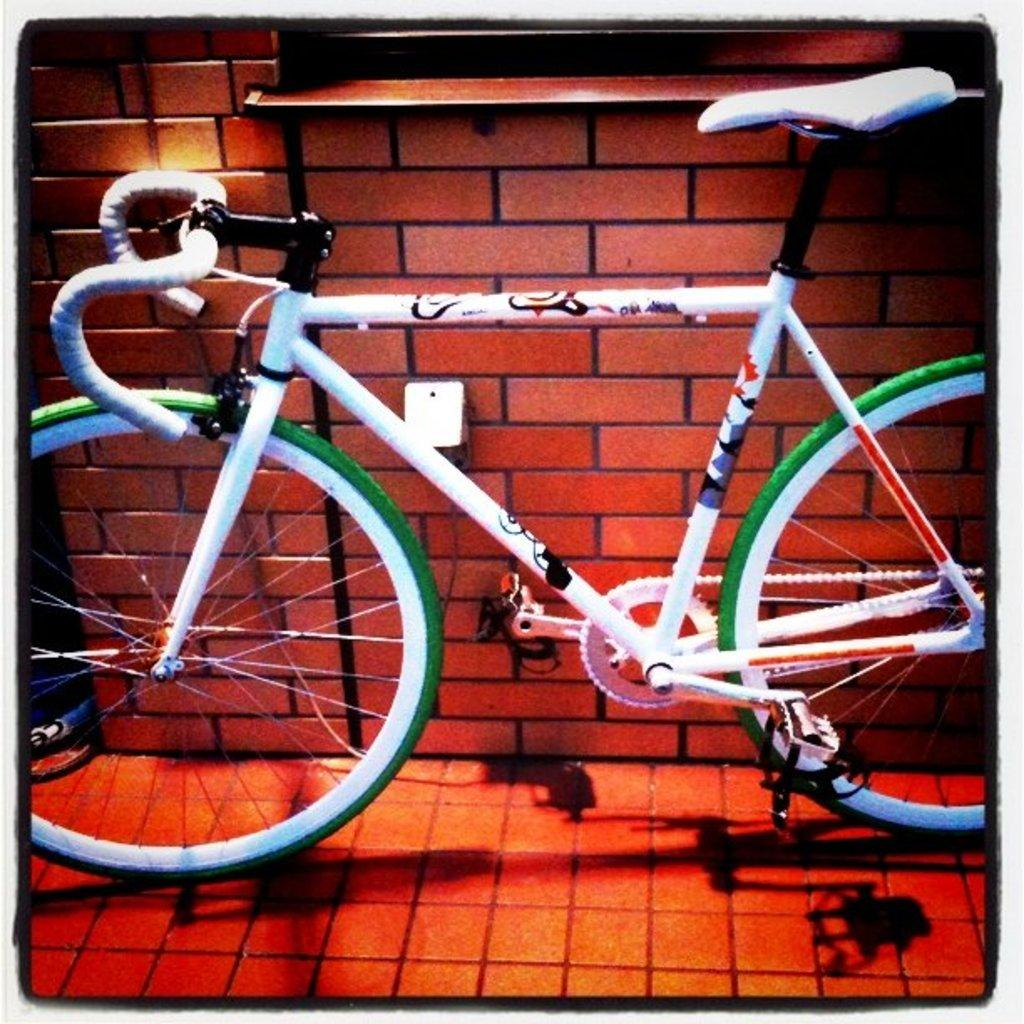What is the main subject of the picture? The main subject of the picture is a bicycle. What color is the bicycle? The bicycle is white in color. What else can be seen in the picture besides the bicycle? There is a brick wall in the picture. How many brains can be seen on the bicycle in the image? There are no brains visible on the bicycle in the image. What type of ear is attached to the bicycle in the image? There is no ear attached to the bicycle in the image. 